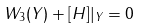Convert formula to latex. <formula><loc_0><loc_0><loc_500><loc_500>W _ { 3 } ( Y ) + [ H ] | _ { Y } = 0</formula> 